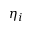Convert formula to latex. <formula><loc_0><loc_0><loc_500><loc_500>\eta _ { i }</formula> 